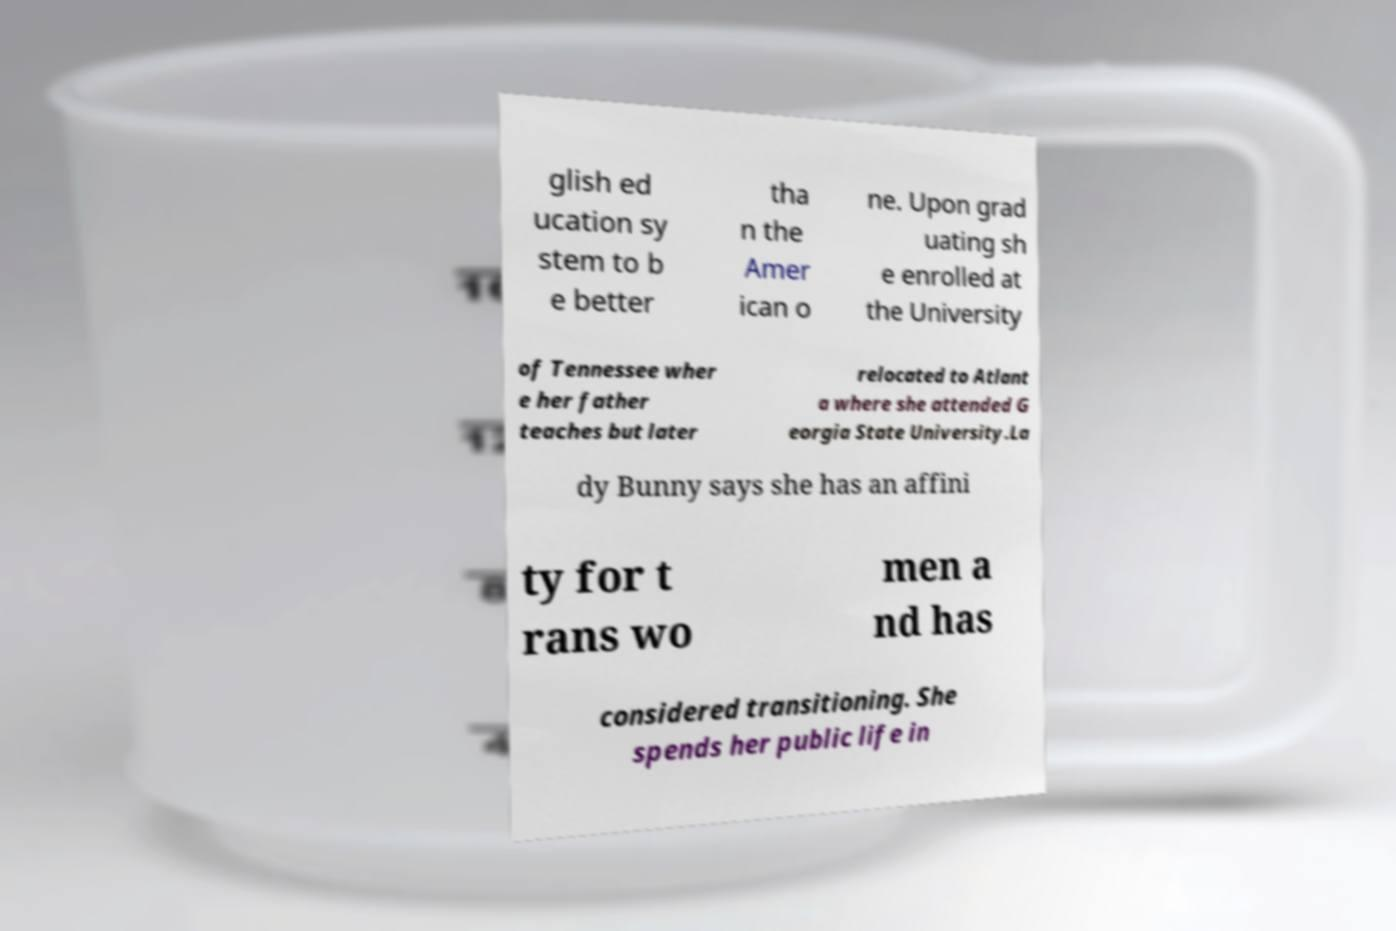For documentation purposes, I need the text within this image transcribed. Could you provide that? glish ed ucation sy stem to b e better tha n the Amer ican o ne. Upon grad uating sh e enrolled at the University of Tennessee wher e her father teaches but later relocated to Atlant a where she attended G eorgia State University.La dy Bunny says she has an affini ty for t rans wo men a nd has considered transitioning. She spends her public life in 